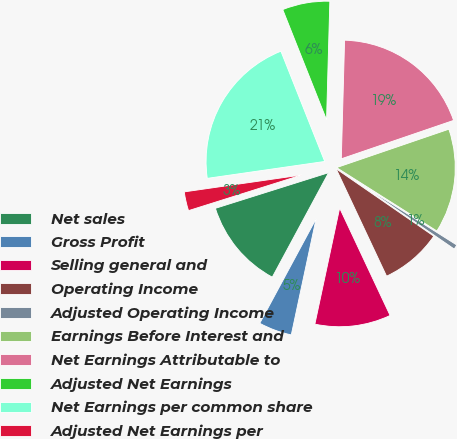Convert chart to OTSL. <chart><loc_0><loc_0><loc_500><loc_500><pie_chart><fcel>Net sales<fcel>Gross Profit<fcel>Selling general and<fcel>Operating Income<fcel>Adjusted Operating Income<fcel>Earnings Before Interest and<fcel>Net Earnings Attributable to<fcel>Adjusted Net Earnings<fcel>Net Earnings per common share<fcel>Adjusted Net Earnings per<nl><fcel>12.28%<fcel>4.52%<fcel>10.34%<fcel>8.4%<fcel>0.64%<fcel>14.22%<fcel>19.32%<fcel>6.46%<fcel>21.26%<fcel>2.58%<nl></chart> 